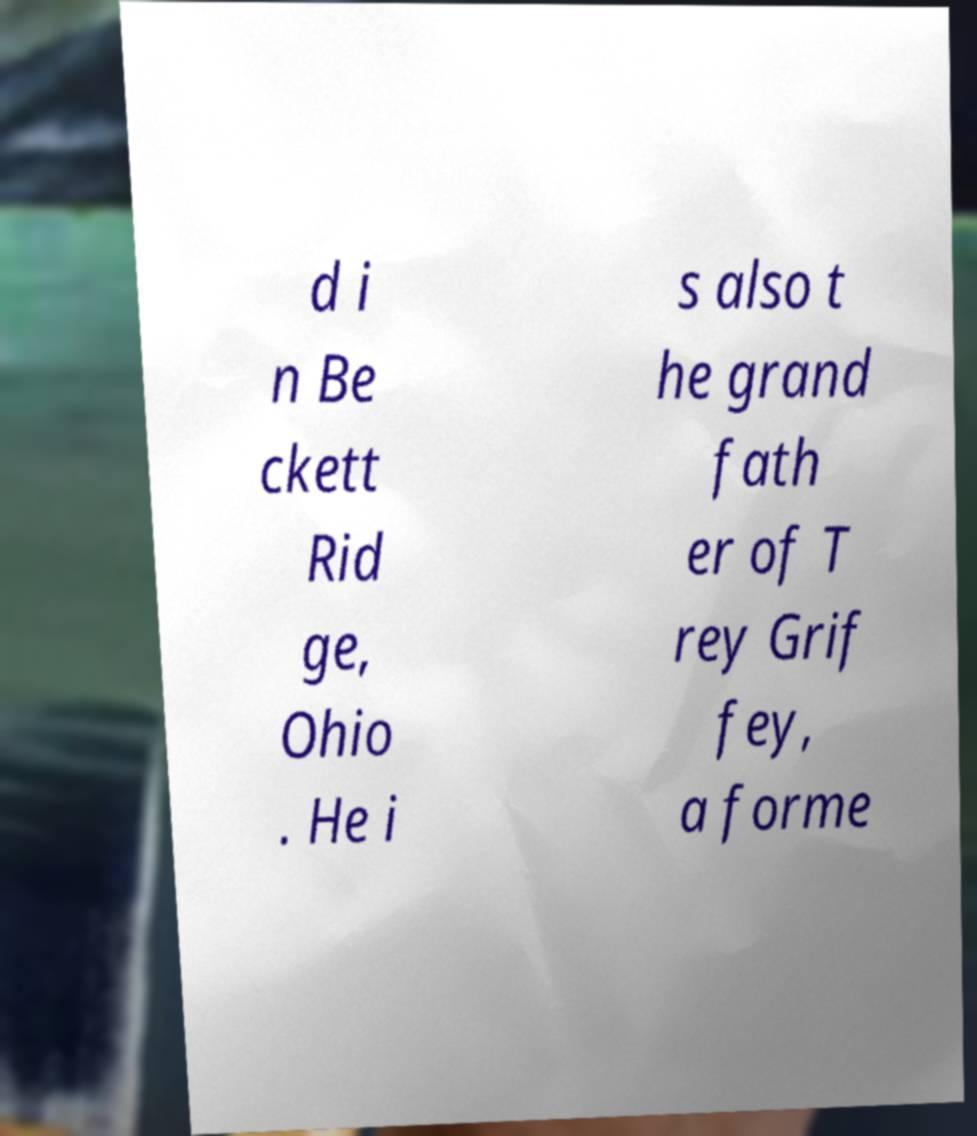Please identify and transcribe the text found in this image. d i n Be ckett Rid ge, Ohio . He i s also t he grand fath er of T rey Grif fey, a forme 